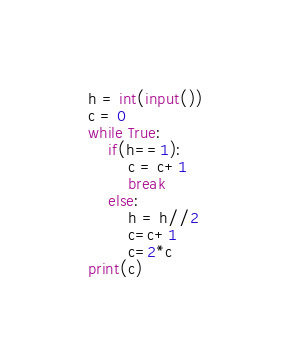Convert code to text. <code><loc_0><loc_0><loc_500><loc_500><_Python_>h = int(input())
c = 0
while True:
    if(h==1):
        c = c+1
        break
    else:
        h = h//2
        c=c+1
        c=2*c
print(c)
</code> 